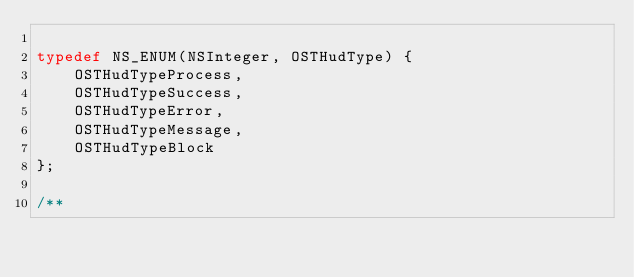Convert code to text. <code><loc_0><loc_0><loc_500><loc_500><_C_>
typedef NS_ENUM(NSInteger, OSTHudType) {
    OSTHudTypeProcess,
    OSTHudTypeSuccess,
    OSTHudTypeError,
    OSTHudTypeMessage,
    OSTHudTypeBlock
};

/**</code> 